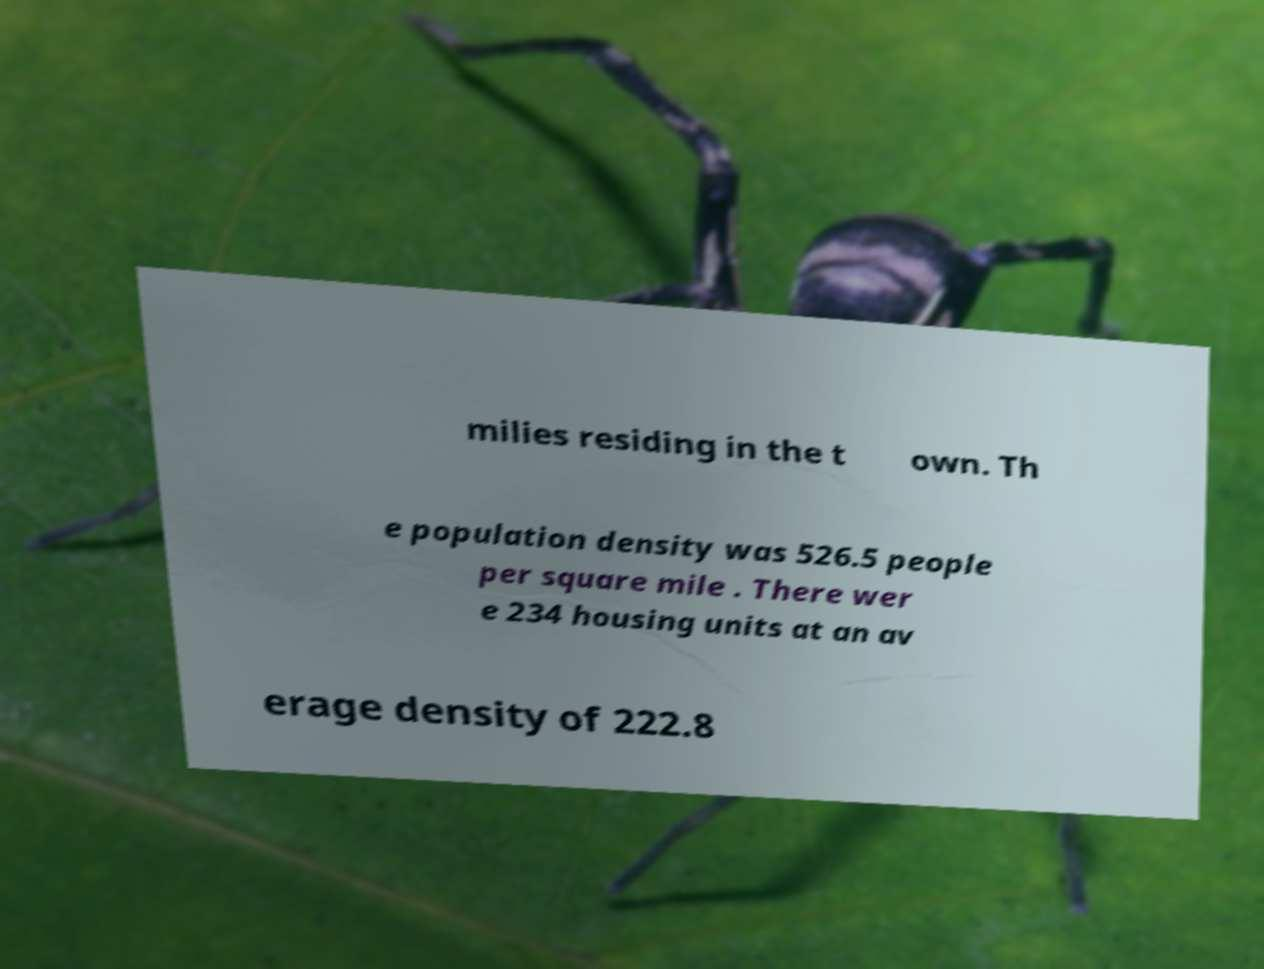What messages or text are displayed in this image? I need them in a readable, typed format. milies residing in the t own. Th e population density was 526.5 people per square mile . There wer e 234 housing units at an av erage density of 222.8 